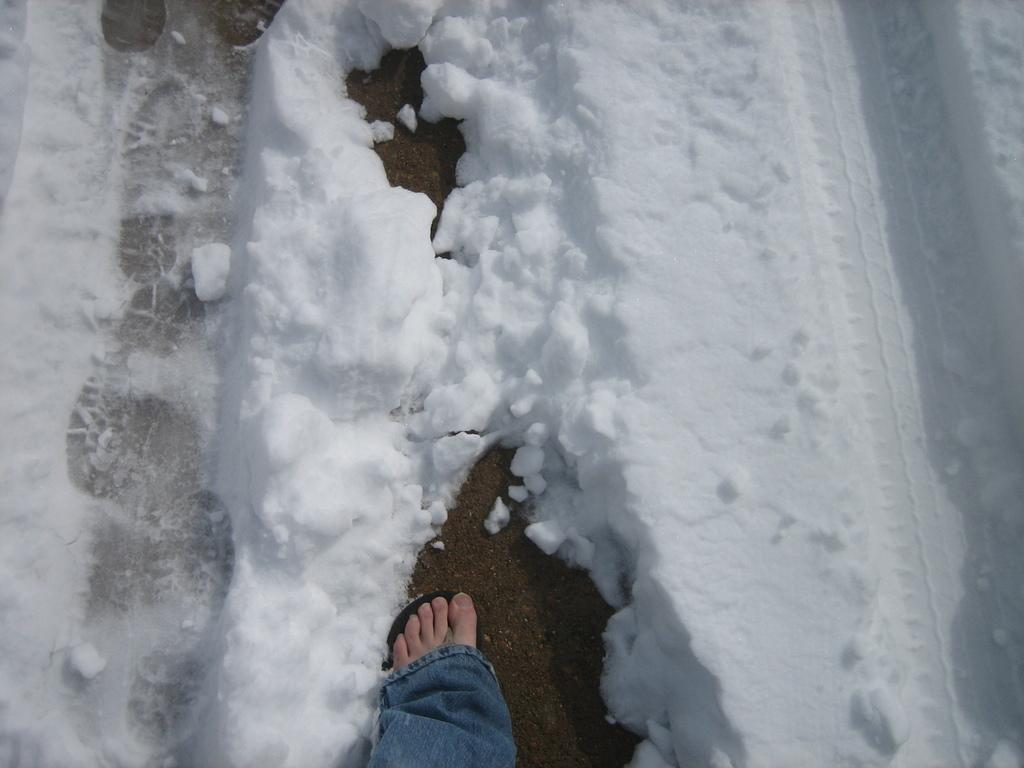What is located at the bottom of the image? There is a leg at the bottom of the image. How is the leg positioned in relation to the snow? The leg is surrounded by snow in the image. What type of border is visible around the leg in the image? There is no border visible around the leg in the image. What book is the leg holding in the image? There is no book present in the image; it only features a leg surrounded by snow. 